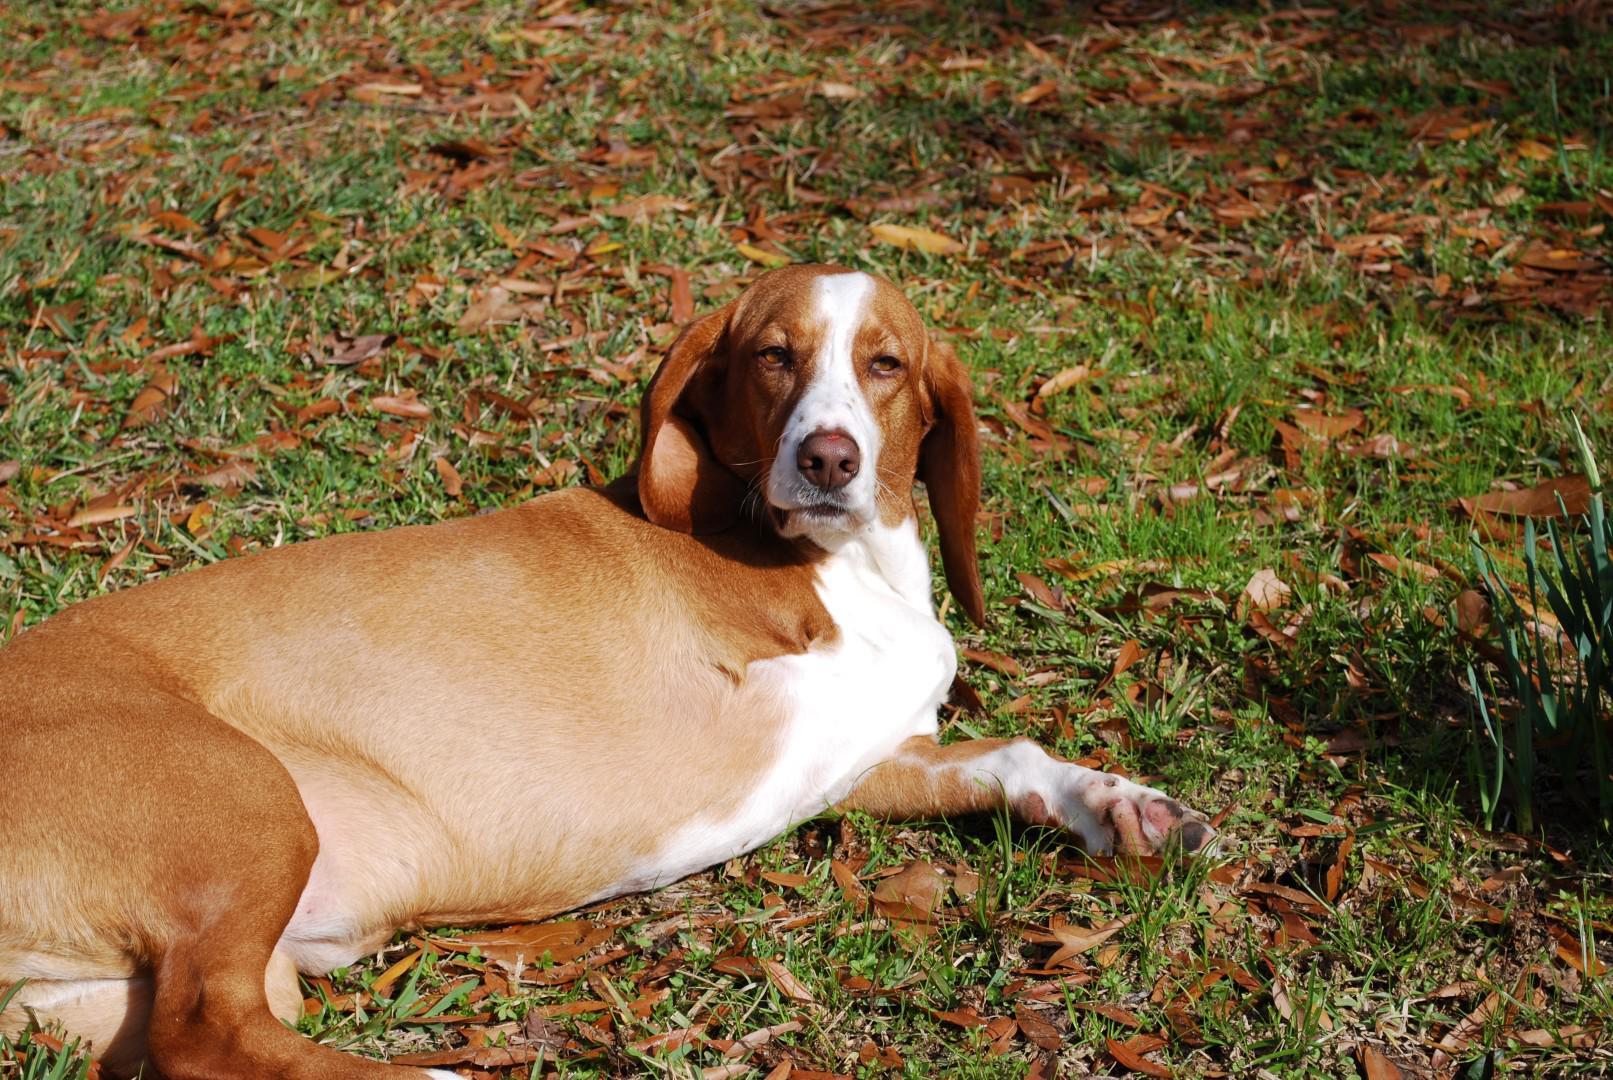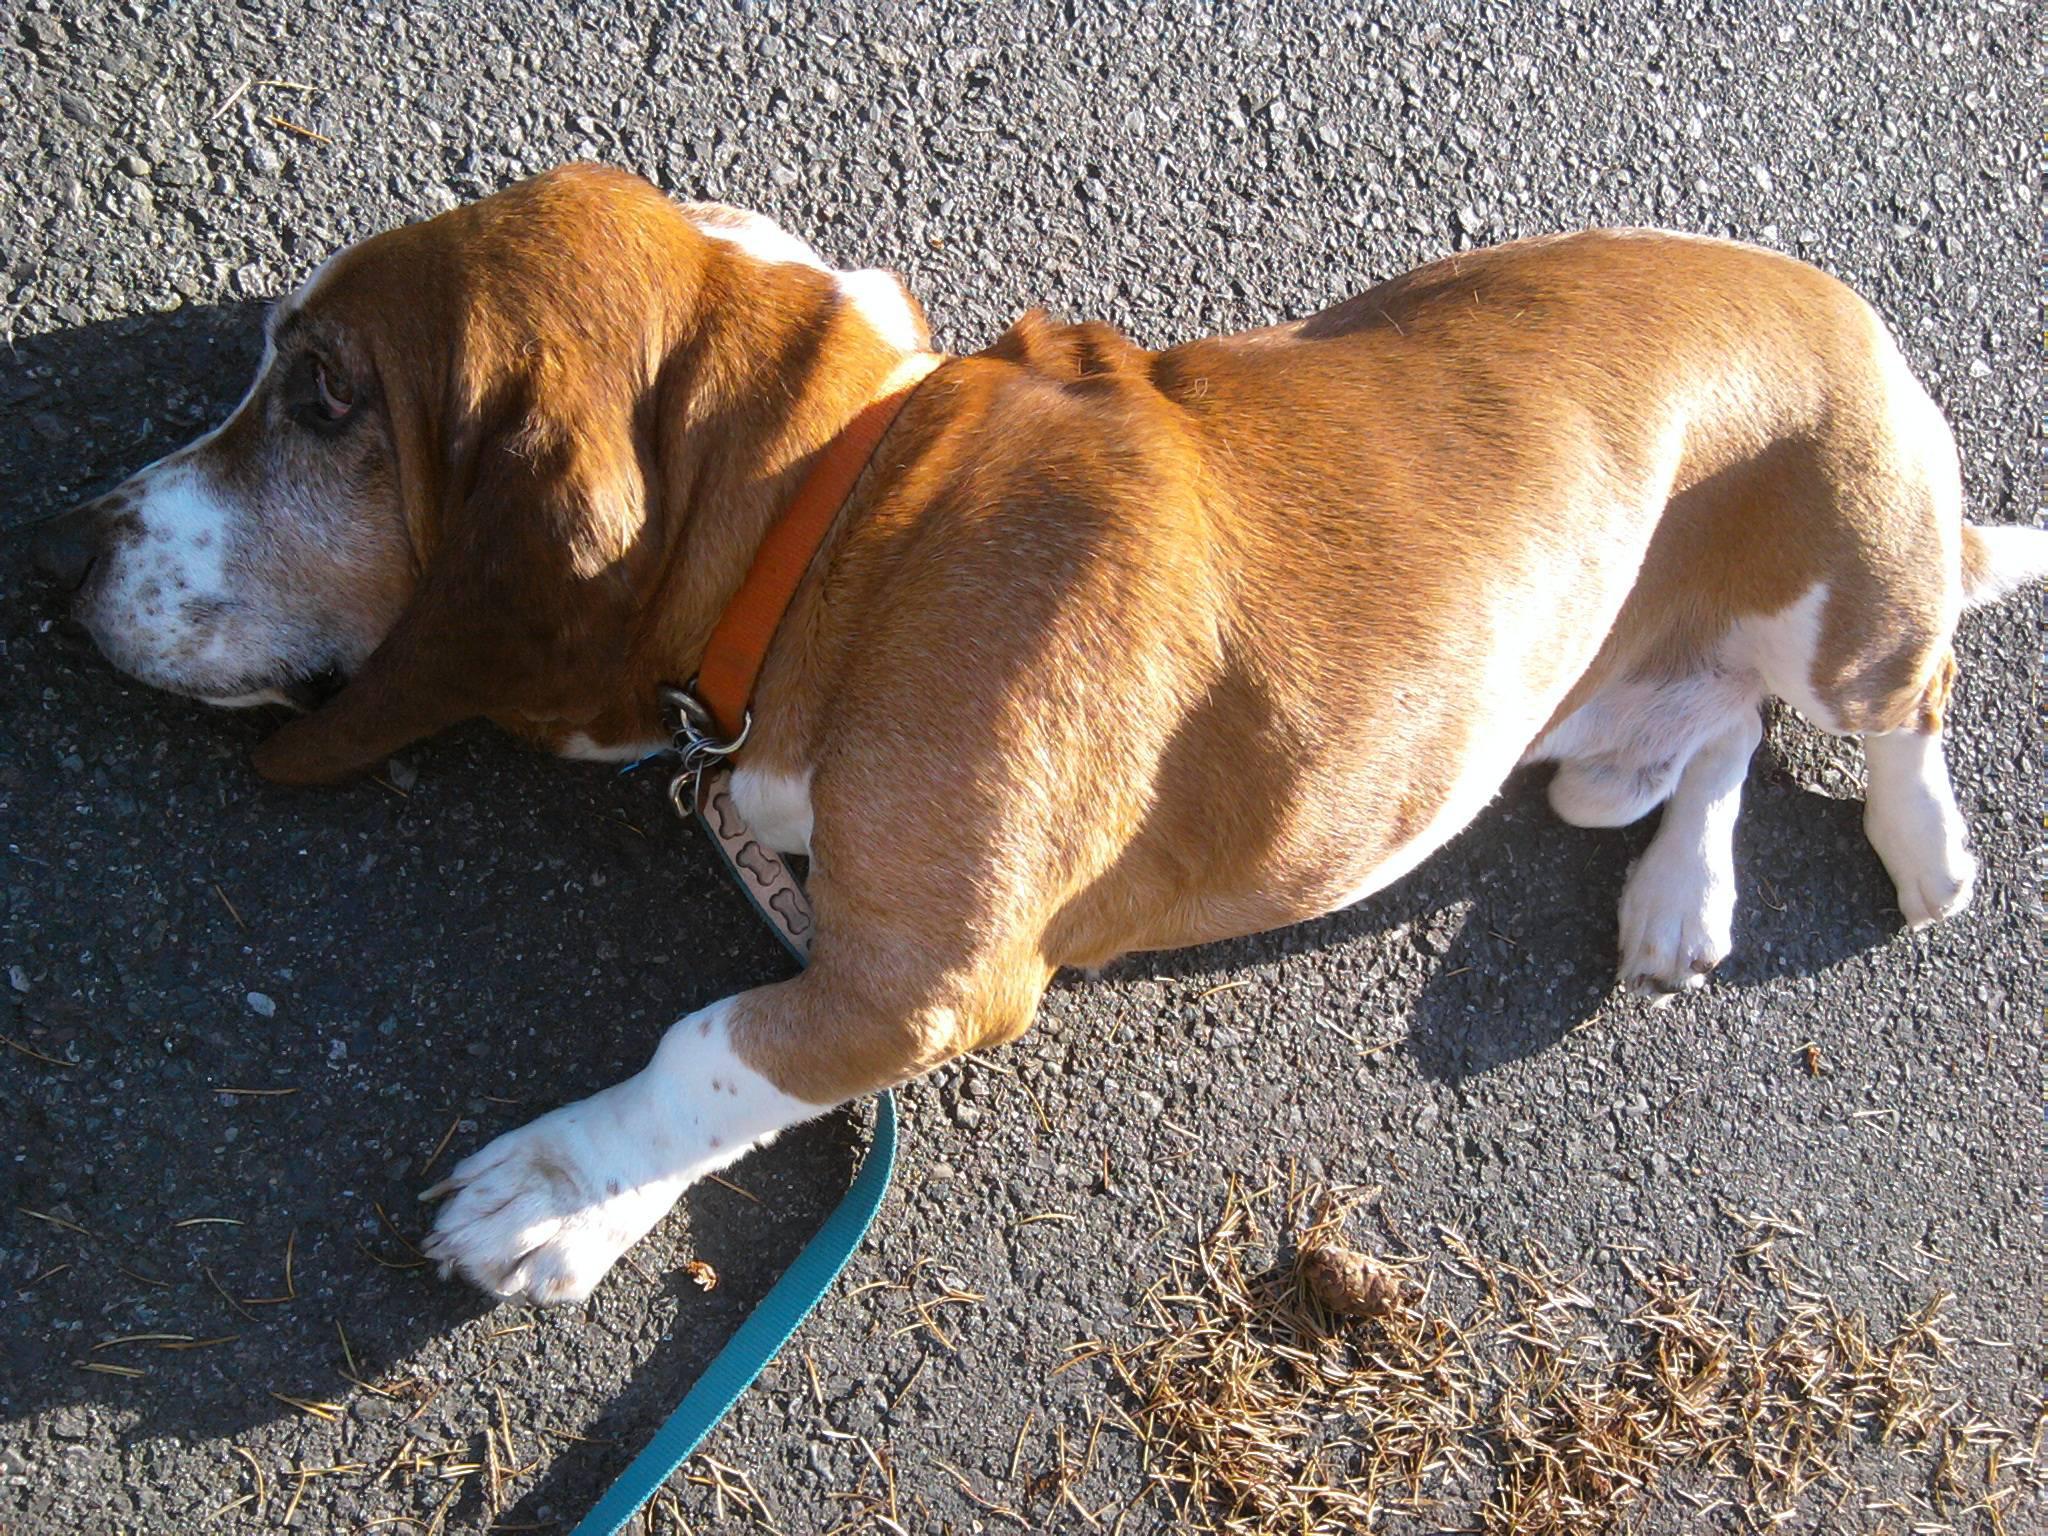The first image is the image on the left, the second image is the image on the right. Given the left and right images, does the statement "The dog in the left image is looking towards the camera." hold true? Answer yes or no. Yes. The first image is the image on the left, the second image is the image on the right. Examine the images to the left and right. Is the description "An image shows a basset hound wearing a front foot prosthetic." accurate? Answer yes or no. No. 